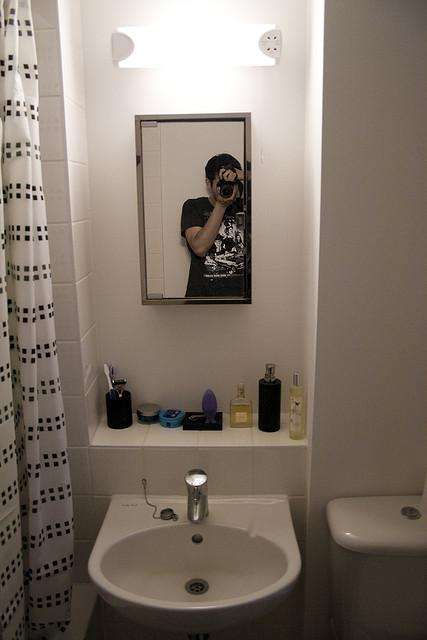A digital single lens reflex is normally known as?

Choices:
A) dssl
B) dlrs
C) dssl
D) dslr dslr 